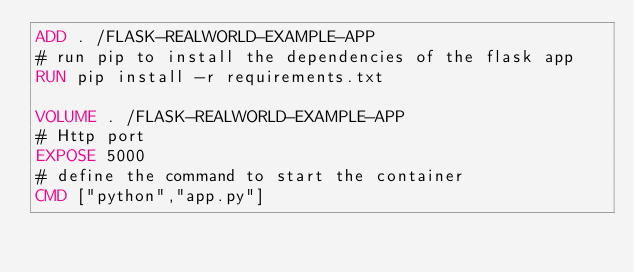<code> <loc_0><loc_0><loc_500><loc_500><_Dockerfile_>ADD . /FLASK-REALWORLD-EXAMPLE-APP
# run pip to install the dependencies of the flask app
RUN pip install -r requirements.txt

VOLUME . /FLASK-REALWORLD-EXAMPLE-APP
# Http port
EXPOSE 5000
# define the command to start the container
CMD ["python","app.py"]
</code> 